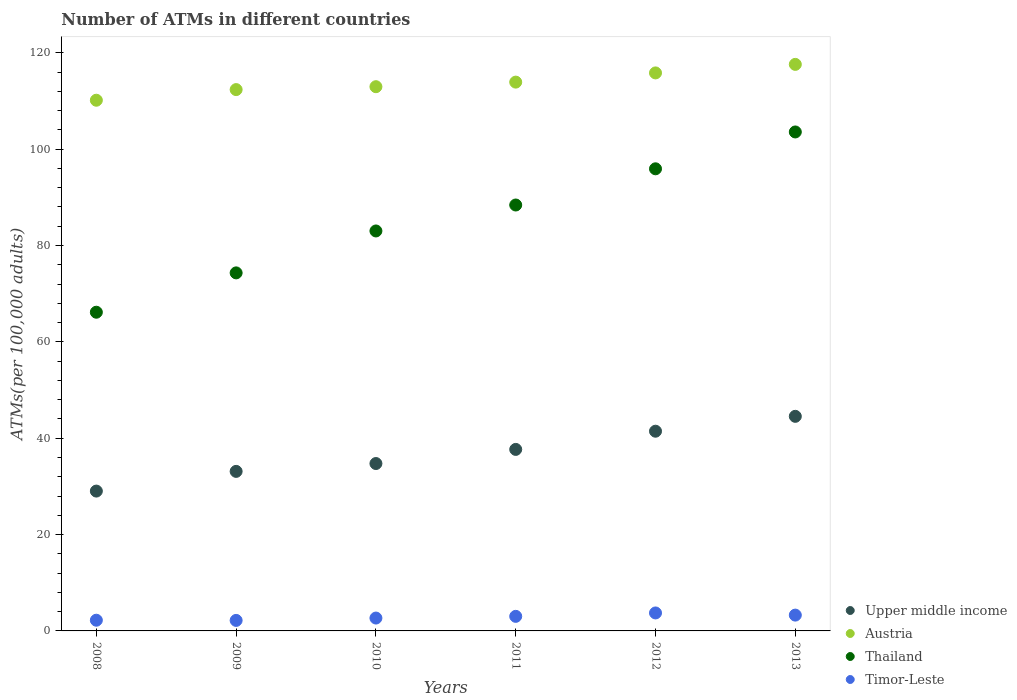How many different coloured dotlines are there?
Your answer should be very brief. 4. Is the number of dotlines equal to the number of legend labels?
Keep it short and to the point. Yes. What is the number of ATMs in Thailand in 2009?
Your answer should be compact. 74.32. Across all years, what is the maximum number of ATMs in Upper middle income?
Ensure brevity in your answer.  44.54. Across all years, what is the minimum number of ATMs in Thailand?
Your answer should be compact. 66.15. In which year was the number of ATMs in Thailand minimum?
Give a very brief answer. 2008. What is the total number of ATMs in Thailand in the graph?
Make the answer very short. 511.39. What is the difference between the number of ATMs in Austria in 2008 and that in 2009?
Your response must be concise. -2.21. What is the difference between the number of ATMs in Austria in 2012 and the number of ATMs in Upper middle income in 2009?
Provide a succinct answer. 82.71. What is the average number of ATMs in Austria per year?
Your answer should be very brief. 113.8. In the year 2012, what is the difference between the number of ATMs in Timor-Leste and number of ATMs in Upper middle income?
Give a very brief answer. -37.72. In how many years, is the number of ATMs in Austria greater than 112?
Keep it short and to the point. 5. What is the ratio of the number of ATMs in Thailand in 2009 to that in 2012?
Offer a terse response. 0.77. Is the number of ATMs in Thailand in 2012 less than that in 2013?
Keep it short and to the point. Yes. What is the difference between the highest and the second highest number of ATMs in Austria?
Offer a terse response. 1.77. What is the difference between the highest and the lowest number of ATMs in Austria?
Give a very brief answer. 7.44. Is it the case that in every year, the sum of the number of ATMs in Austria and number of ATMs in Thailand  is greater than the number of ATMs in Timor-Leste?
Offer a very short reply. Yes. Is the number of ATMs in Upper middle income strictly greater than the number of ATMs in Austria over the years?
Offer a terse response. No. Are the values on the major ticks of Y-axis written in scientific E-notation?
Offer a terse response. No. How many legend labels are there?
Provide a succinct answer. 4. What is the title of the graph?
Ensure brevity in your answer.  Number of ATMs in different countries. Does "Azerbaijan" appear as one of the legend labels in the graph?
Provide a short and direct response. No. What is the label or title of the X-axis?
Make the answer very short. Years. What is the label or title of the Y-axis?
Provide a short and direct response. ATMs(per 100,0 adults). What is the ATMs(per 100,000 adults) of Upper middle income in 2008?
Provide a succinct answer. 29.03. What is the ATMs(per 100,000 adults) in Austria in 2008?
Your answer should be compact. 110.16. What is the ATMs(per 100,000 adults) in Thailand in 2008?
Provide a succinct answer. 66.15. What is the ATMs(per 100,000 adults) of Timor-Leste in 2008?
Your response must be concise. 2.22. What is the ATMs(per 100,000 adults) in Upper middle income in 2009?
Offer a very short reply. 33.12. What is the ATMs(per 100,000 adults) in Austria in 2009?
Offer a terse response. 112.36. What is the ATMs(per 100,000 adults) in Thailand in 2009?
Your answer should be very brief. 74.32. What is the ATMs(per 100,000 adults) of Timor-Leste in 2009?
Ensure brevity in your answer.  2.18. What is the ATMs(per 100,000 adults) in Upper middle income in 2010?
Your answer should be compact. 34.74. What is the ATMs(per 100,000 adults) in Austria in 2010?
Your answer should be very brief. 112.97. What is the ATMs(per 100,000 adults) of Thailand in 2010?
Offer a very short reply. 83.02. What is the ATMs(per 100,000 adults) of Timor-Leste in 2010?
Give a very brief answer. 2.67. What is the ATMs(per 100,000 adults) of Upper middle income in 2011?
Your answer should be very brief. 37.68. What is the ATMs(per 100,000 adults) of Austria in 2011?
Ensure brevity in your answer.  113.92. What is the ATMs(per 100,000 adults) of Thailand in 2011?
Give a very brief answer. 88.41. What is the ATMs(per 100,000 adults) in Timor-Leste in 2011?
Offer a terse response. 3.02. What is the ATMs(per 100,000 adults) of Upper middle income in 2012?
Give a very brief answer. 41.45. What is the ATMs(per 100,000 adults) in Austria in 2012?
Your answer should be compact. 115.83. What is the ATMs(per 100,000 adults) of Thailand in 2012?
Your answer should be very brief. 95.92. What is the ATMs(per 100,000 adults) in Timor-Leste in 2012?
Your answer should be very brief. 3.73. What is the ATMs(per 100,000 adults) of Upper middle income in 2013?
Make the answer very short. 44.54. What is the ATMs(per 100,000 adults) of Austria in 2013?
Your response must be concise. 117.6. What is the ATMs(per 100,000 adults) of Thailand in 2013?
Your answer should be compact. 103.57. What is the ATMs(per 100,000 adults) in Timor-Leste in 2013?
Your response must be concise. 3.28. Across all years, what is the maximum ATMs(per 100,000 adults) of Upper middle income?
Provide a succinct answer. 44.54. Across all years, what is the maximum ATMs(per 100,000 adults) of Austria?
Your answer should be very brief. 117.6. Across all years, what is the maximum ATMs(per 100,000 adults) in Thailand?
Provide a succinct answer. 103.57. Across all years, what is the maximum ATMs(per 100,000 adults) of Timor-Leste?
Ensure brevity in your answer.  3.73. Across all years, what is the minimum ATMs(per 100,000 adults) of Upper middle income?
Provide a short and direct response. 29.03. Across all years, what is the minimum ATMs(per 100,000 adults) in Austria?
Provide a short and direct response. 110.16. Across all years, what is the minimum ATMs(per 100,000 adults) of Thailand?
Ensure brevity in your answer.  66.15. Across all years, what is the minimum ATMs(per 100,000 adults) in Timor-Leste?
Make the answer very short. 2.18. What is the total ATMs(per 100,000 adults) in Upper middle income in the graph?
Ensure brevity in your answer.  220.56. What is the total ATMs(per 100,000 adults) of Austria in the graph?
Your answer should be compact. 682.82. What is the total ATMs(per 100,000 adults) of Thailand in the graph?
Make the answer very short. 511.39. What is the total ATMs(per 100,000 adults) of Timor-Leste in the graph?
Your answer should be very brief. 17.11. What is the difference between the ATMs(per 100,000 adults) of Upper middle income in 2008 and that in 2009?
Your answer should be compact. -4.09. What is the difference between the ATMs(per 100,000 adults) in Austria in 2008 and that in 2009?
Offer a terse response. -2.21. What is the difference between the ATMs(per 100,000 adults) in Thailand in 2008 and that in 2009?
Your answer should be compact. -8.17. What is the difference between the ATMs(per 100,000 adults) of Timor-Leste in 2008 and that in 2009?
Keep it short and to the point. 0.04. What is the difference between the ATMs(per 100,000 adults) in Upper middle income in 2008 and that in 2010?
Provide a short and direct response. -5.72. What is the difference between the ATMs(per 100,000 adults) in Austria in 2008 and that in 2010?
Ensure brevity in your answer.  -2.81. What is the difference between the ATMs(per 100,000 adults) in Thailand in 2008 and that in 2010?
Your answer should be compact. -16.87. What is the difference between the ATMs(per 100,000 adults) of Timor-Leste in 2008 and that in 2010?
Offer a very short reply. -0.45. What is the difference between the ATMs(per 100,000 adults) in Upper middle income in 2008 and that in 2011?
Ensure brevity in your answer.  -8.65. What is the difference between the ATMs(per 100,000 adults) in Austria in 2008 and that in 2011?
Offer a terse response. -3.76. What is the difference between the ATMs(per 100,000 adults) of Thailand in 2008 and that in 2011?
Give a very brief answer. -22.26. What is the difference between the ATMs(per 100,000 adults) in Timor-Leste in 2008 and that in 2011?
Provide a succinct answer. -0.8. What is the difference between the ATMs(per 100,000 adults) of Upper middle income in 2008 and that in 2012?
Offer a terse response. -12.43. What is the difference between the ATMs(per 100,000 adults) in Austria in 2008 and that in 2012?
Offer a terse response. -5.67. What is the difference between the ATMs(per 100,000 adults) in Thailand in 2008 and that in 2012?
Your answer should be compact. -29.77. What is the difference between the ATMs(per 100,000 adults) in Timor-Leste in 2008 and that in 2012?
Your response must be concise. -1.51. What is the difference between the ATMs(per 100,000 adults) of Upper middle income in 2008 and that in 2013?
Provide a succinct answer. -15.51. What is the difference between the ATMs(per 100,000 adults) of Austria in 2008 and that in 2013?
Keep it short and to the point. -7.44. What is the difference between the ATMs(per 100,000 adults) in Thailand in 2008 and that in 2013?
Provide a short and direct response. -37.42. What is the difference between the ATMs(per 100,000 adults) in Timor-Leste in 2008 and that in 2013?
Keep it short and to the point. -1.06. What is the difference between the ATMs(per 100,000 adults) in Upper middle income in 2009 and that in 2010?
Provide a succinct answer. -1.63. What is the difference between the ATMs(per 100,000 adults) in Austria in 2009 and that in 2010?
Your answer should be compact. -0.6. What is the difference between the ATMs(per 100,000 adults) of Thailand in 2009 and that in 2010?
Your answer should be very brief. -8.7. What is the difference between the ATMs(per 100,000 adults) of Timor-Leste in 2009 and that in 2010?
Make the answer very short. -0.49. What is the difference between the ATMs(per 100,000 adults) in Upper middle income in 2009 and that in 2011?
Make the answer very short. -4.56. What is the difference between the ATMs(per 100,000 adults) in Austria in 2009 and that in 2011?
Offer a terse response. -1.55. What is the difference between the ATMs(per 100,000 adults) in Thailand in 2009 and that in 2011?
Provide a succinct answer. -14.09. What is the difference between the ATMs(per 100,000 adults) in Timor-Leste in 2009 and that in 2011?
Your answer should be compact. -0.84. What is the difference between the ATMs(per 100,000 adults) in Upper middle income in 2009 and that in 2012?
Provide a short and direct response. -8.34. What is the difference between the ATMs(per 100,000 adults) of Austria in 2009 and that in 2012?
Your answer should be very brief. -3.46. What is the difference between the ATMs(per 100,000 adults) of Thailand in 2009 and that in 2012?
Provide a short and direct response. -21.6. What is the difference between the ATMs(per 100,000 adults) in Timor-Leste in 2009 and that in 2012?
Make the answer very short. -1.55. What is the difference between the ATMs(per 100,000 adults) in Upper middle income in 2009 and that in 2013?
Give a very brief answer. -11.43. What is the difference between the ATMs(per 100,000 adults) in Austria in 2009 and that in 2013?
Offer a very short reply. -5.23. What is the difference between the ATMs(per 100,000 adults) of Thailand in 2009 and that in 2013?
Keep it short and to the point. -29.25. What is the difference between the ATMs(per 100,000 adults) of Timor-Leste in 2009 and that in 2013?
Offer a terse response. -1.1. What is the difference between the ATMs(per 100,000 adults) of Upper middle income in 2010 and that in 2011?
Your answer should be very brief. -2.93. What is the difference between the ATMs(per 100,000 adults) in Austria in 2010 and that in 2011?
Offer a terse response. -0.95. What is the difference between the ATMs(per 100,000 adults) in Thailand in 2010 and that in 2011?
Your answer should be very brief. -5.39. What is the difference between the ATMs(per 100,000 adults) of Timor-Leste in 2010 and that in 2011?
Offer a terse response. -0.35. What is the difference between the ATMs(per 100,000 adults) in Upper middle income in 2010 and that in 2012?
Your response must be concise. -6.71. What is the difference between the ATMs(per 100,000 adults) of Austria in 2010 and that in 2012?
Offer a terse response. -2.86. What is the difference between the ATMs(per 100,000 adults) of Thailand in 2010 and that in 2012?
Offer a terse response. -12.9. What is the difference between the ATMs(per 100,000 adults) of Timor-Leste in 2010 and that in 2012?
Ensure brevity in your answer.  -1.06. What is the difference between the ATMs(per 100,000 adults) in Upper middle income in 2010 and that in 2013?
Ensure brevity in your answer.  -9.8. What is the difference between the ATMs(per 100,000 adults) of Austria in 2010 and that in 2013?
Give a very brief answer. -4.63. What is the difference between the ATMs(per 100,000 adults) in Thailand in 2010 and that in 2013?
Provide a short and direct response. -20.55. What is the difference between the ATMs(per 100,000 adults) in Timor-Leste in 2010 and that in 2013?
Provide a short and direct response. -0.61. What is the difference between the ATMs(per 100,000 adults) in Upper middle income in 2011 and that in 2012?
Keep it short and to the point. -3.78. What is the difference between the ATMs(per 100,000 adults) in Austria in 2011 and that in 2012?
Your response must be concise. -1.91. What is the difference between the ATMs(per 100,000 adults) in Thailand in 2011 and that in 2012?
Provide a succinct answer. -7.51. What is the difference between the ATMs(per 100,000 adults) of Timor-Leste in 2011 and that in 2012?
Your answer should be very brief. -0.7. What is the difference between the ATMs(per 100,000 adults) of Upper middle income in 2011 and that in 2013?
Keep it short and to the point. -6.86. What is the difference between the ATMs(per 100,000 adults) of Austria in 2011 and that in 2013?
Provide a short and direct response. -3.68. What is the difference between the ATMs(per 100,000 adults) of Thailand in 2011 and that in 2013?
Offer a terse response. -15.16. What is the difference between the ATMs(per 100,000 adults) of Timor-Leste in 2011 and that in 2013?
Provide a short and direct response. -0.26. What is the difference between the ATMs(per 100,000 adults) in Upper middle income in 2012 and that in 2013?
Your response must be concise. -3.09. What is the difference between the ATMs(per 100,000 adults) in Austria in 2012 and that in 2013?
Provide a succinct answer. -1.77. What is the difference between the ATMs(per 100,000 adults) of Thailand in 2012 and that in 2013?
Keep it short and to the point. -7.65. What is the difference between the ATMs(per 100,000 adults) of Timor-Leste in 2012 and that in 2013?
Keep it short and to the point. 0.45. What is the difference between the ATMs(per 100,000 adults) of Upper middle income in 2008 and the ATMs(per 100,000 adults) of Austria in 2009?
Make the answer very short. -83.34. What is the difference between the ATMs(per 100,000 adults) in Upper middle income in 2008 and the ATMs(per 100,000 adults) in Thailand in 2009?
Provide a succinct answer. -45.29. What is the difference between the ATMs(per 100,000 adults) in Upper middle income in 2008 and the ATMs(per 100,000 adults) in Timor-Leste in 2009?
Make the answer very short. 26.85. What is the difference between the ATMs(per 100,000 adults) in Austria in 2008 and the ATMs(per 100,000 adults) in Thailand in 2009?
Offer a terse response. 35.84. What is the difference between the ATMs(per 100,000 adults) in Austria in 2008 and the ATMs(per 100,000 adults) in Timor-Leste in 2009?
Offer a terse response. 107.97. What is the difference between the ATMs(per 100,000 adults) of Thailand in 2008 and the ATMs(per 100,000 adults) of Timor-Leste in 2009?
Offer a very short reply. 63.97. What is the difference between the ATMs(per 100,000 adults) of Upper middle income in 2008 and the ATMs(per 100,000 adults) of Austria in 2010?
Provide a short and direct response. -83.94. What is the difference between the ATMs(per 100,000 adults) in Upper middle income in 2008 and the ATMs(per 100,000 adults) in Thailand in 2010?
Make the answer very short. -53.99. What is the difference between the ATMs(per 100,000 adults) of Upper middle income in 2008 and the ATMs(per 100,000 adults) of Timor-Leste in 2010?
Your answer should be compact. 26.36. What is the difference between the ATMs(per 100,000 adults) of Austria in 2008 and the ATMs(per 100,000 adults) of Thailand in 2010?
Offer a very short reply. 27.14. What is the difference between the ATMs(per 100,000 adults) in Austria in 2008 and the ATMs(per 100,000 adults) in Timor-Leste in 2010?
Your answer should be very brief. 107.49. What is the difference between the ATMs(per 100,000 adults) in Thailand in 2008 and the ATMs(per 100,000 adults) in Timor-Leste in 2010?
Offer a very short reply. 63.48. What is the difference between the ATMs(per 100,000 adults) in Upper middle income in 2008 and the ATMs(per 100,000 adults) in Austria in 2011?
Provide a short and direct response. -84.89. What is the difference between the ATMs(per 100,000 adults) in Upper middle income in 2008 and the ATMs(per 100,000 adults) in Thailand in 2011?
Make the answer very short. -59.38. What is the difference between the ATMs(per 100,000 adults) in Upper middle income in 2008 and the ATMs(per 100,000 adults) in Timor-Leste in 2011?
Offer a very short reply. 26. What is the difference between the ATMs(per 100,000 adults) of Austria in 2008 and the ATMs(per 100,000 adults) of Thailand in 2011?
Keep it short and to the point. 21.75. What is the difference between the ATMs(per 100,000 adults) in Austria in 2008 and the ATMs(per 100,000 adults) in Timor-Leste in 2011?
Your response must be concise. 107.13. What is the difference between the ATMs(per 100,000 adults) of Thailand in 2008 and the ATMs(per 100,000 adults) of Timor-Leste in 2011?
Your response must be concise. 63.13. What is the difference between the ATMs(per 100,000 adults) in Upper middle income in 2008 and the ATMs(per 100,000 adults) in Austria in 2012?
Your response must be concise. -86.8. What is the difference between the ATMs(per 100,000 adults) of Upper middle income in 2008 and the ATMs(per 100,000 adults) of Thailand in 2012?
Ensure brevity in your answer.  -66.9. What is the difference between the ATMs(per 100,000 adults) in Upper middle income in 2008 and the ATMs(per 100,000 adults) in Timor-Leste in 2012?
Your answer should be very brief. 25.3. What is the difference between the ATMs(per 100,000 adults) of Austria in 2008 and the ATMs(per 100,000 adults) of Thailand in 2012?
Keep it short and to the point. 14.23. What is the difference between the ATMs(per 100,000 adults) in Austria in 2008 and the ATMs(per 100,000 adults) in Timor-Leste in 2012?
Your answer should be very brief. 106.43. What is the difference between the ATMs(per 100,000 adults) in Thailand in 2008 and the ATMs(per 100,000 adults) in Timor-Leste in 2012?
Provide a short and direct response. 62.42. What is the difference between the ATMs(per 100,000 adults) in Upper middle income in 2008 and the ATMs(per 100,000 adults) in Austria in 2013?
Keep it short and to the point. -88.57. What is the difference between the ATMs(per 100,000 adults) of Upper middle income in 2008 and the ATMs(per 100,000 adults) of Thailand in 2013?
Your response must be concise. -74.54. What is the difference between the ATMs(per 100,000 adults) of Upper middle income in 2008 and the ATMs(per 100,000 adults) of Timor-Leste in 2013?
Make the answer very short. 25.74. What is the difference between the ATMs(per 100,000 adults) of Austria in 2008 and the ATMs(per 100,000 adults) of Thailand in 2013?
Your answer should be very brief. 6.59. What is the difference between the ATMs(per 100,000 adults) of Austria in 2008 and the ATMs(per 100,000 adults) of Timor-Leste in 2013?
Your response must be concise. 106.87. What is the difference between the ATMs(per 100,000 adults) in Thailand in 2008 and the ATMs(per 100,000 adults) in Timor-Leste in 2013?
Your response must be concise. 62.87. What is the difference between the ATMs(per 100,000 adults) in Upper middle income in 2009 and the ATMs(per 100,000 adults) in Austria in 2010?
Offer a very short reply. -79.85. What is the difference between the ATMs(per 100,000 adults) of Upper middle income in 2009 and the ATMs(per 100,000 adults) of Thailand in 2010?
Make the answer very short. -49.91. What is the difference between the ATMs(per 100,000 adults) of Upper middle income in 2009 and the ATMs(per 100,000 adults) of Timor-Leste in 2010?
Give a very brief answer. 30.44. What is the difference between the ATMs(per 100,000 adults) of Austria in 2009 and the ATMs(per 100,000 adults) of Thailand in 2010?
Provide a succinct answer. 29.34. What is the difference between the ATMs(per 100,000 adults) of Austria in 2009 and the ATMs(per 100,000 adults) of Timor-Leste in 2010?
Make the answer very short. 109.69. What is the difference between the ATMs(per 100,000 adults) of Thailand in 2009 and the ATMs(per 100,000 adults) of Timor-Leste in 2010?
Provide a succinct answer. 71.65. What is the difference between the ATMs(per 100,000 adults) of Upper middle income in 2009 and the ATMs(per 100,000 adults) of Austria in 2011?
Offer a terse response. -80.8. What is the difference between the ATMs(per 100,000 adults) in Upper middle income in 2009 and the ATMs(per 100,000 adults) in Thailand in 2011?
Give a very brief answer. -55.29. What is the difference between the ATMs(per 100,000 adults) of Upper middle income in 2009 and the ATMs(per 100,000 adults) of Timor-Leste in 2011?
Your response must be concise. 30.09. What is the difference between the ATMs(per 100,000 adults) of Austria in 2009 and the ATMs(per 100,000 adults) of Thailand in 2011?
Ensure brevity in your answer.  23.96. What is the difference between the ATMs(per 100,000 adults) of Austria in 2009 and the ATMs(per 100,000 adults) of Timor-Leste in 2011?
Your answer should be very brief. 109.34. What is the difference between the ATMs(per 100,000 adults) of Thailand in 2009 and the ATMs(per 100,000 adults) of Timor-Leste in 2011?
Your answer should be compact. 71.29. What is the difference between the ATMs(per 100,000 adults) in Upper middle income in 2009 and the ATMs(per 100,000 adults) in Austria in 2012?
Your answer should be very brief. -82.71. What is the difference between the ATMs(per 100,000 adults) of Upper middle income in 2009 and the ATMs(per 100,000 adults) of Thailand in 2012?
Give a very brief answer. -62.81. What is the difference between the ATMs(per 100,000 adults) in Upper middle income in 2009 and the ATMs(per 100,000 adults) in Timor-Leste in 2012?
Provide a succinct answer. 29.39. What is the difference between the ATMs(per 100,000 adults) of Austria in 2009 and the ATMs(per 100,000 adults) of Thailand in 2012?
Offer a terse response. 16.44. What is the difference between the ATMs(per 100,000 adults) of Austria in 2009 and the ATMs(per 100,000 adults) of Timor-Leste in 2012?
Offer a very short reply. 108.63. What is the difference between the ATMs(per 100,000 adults) of Thailand in 2009 and the ATMs(per 100,000 adults) of Timor-Leste in 2012?
Your answer should be compact. 70.59. What is the difference between the ATMs(per 100,000 adults) of Upper middle income in 2009 and the ATMs(per 100,000 adults) of Austria in 2013?
Provide a short and direct response. -84.48. What is the difference between the ATMs(per 100,000 adults) of Upper middle income in 2009 and the ATMs(per 100,000 adults) of Thailand in 2013?
Provide a succinct answer. -70.45. What is the difference between the ATMs(per 100,000 adults) in Upper middle income in 2009 and the ATMs(per 100,000 adults) in Timor-Leste in 2013?
Your answer should be compact. 29.83. What is the difference between the ATMs(per 100,000 adults) in Austria in 2009 and the ATMs(per 100,000 adults) in Thailand in 2013?
Give a very brief answer. 8.79. What is the difference between the ATMs(per 100,000 adults) of Austria in 2009 and the ATMs(per 100,000 adults) of Timor-Leste in 2013?
Give a very brief answer. 109.08. What is the difference between the ATMs(per 100,000 adults) of Thailand in 2009 and the ATMs(per 100,000 adults) of Timor-Leste in 2013?
Offer a terse response. 71.04. What is the difference between the ATMs(per 100,000 adults) of Upper middle income in 2010 and the ATMs(per 100,000 adults) of Austria in 2011?
Offer a very short reply. -79.17. What is the difference between the ATMs(per 100,000 adults) in Upper middle income in 2010 and the ATMs(per 100,000 adults) in Thailand in 2011?
Provide a short and direct response. -53.66. What is the difference between the ATMs(per 100,000 adults) of Upper middle income in 2010 and the ATMs(per 100,000 adults) of Timor-Leste in 2011?
Your answer should be compact. 31.72. What is the difference between the ATMs(per 100,000 adults) of Austria in 2010 and the ATMs(per 100,000 adults) of Thailand in 2011?
Ensure brevity in your answer.  24.56. What is the difference between the ATMs(per 100,000 adults) in Austria in 2010 and the ATMs(per 100,000 adults) in Timor-Leste in 2011?
Your answer should be compact. 109.94. What is the difference between the ATMs(per 100,000 adults) of Thailand in 2010 and the ATMs(per 100,000 adults) of Timor-Leste in 2011?
Offer a very short reply. 80. What is the difference between the ATMs(per 100,000 adults) of Upper middle income in 2010 and the ATMs(per 100,000 adults) of Austria in 2012?
Your answer should be very brief. -81.08. What is the difference between the ATMs(per 100,000 adults) in Upper middle income in 2010 and the ATMs(per 100,000 adults) in Thailand in 2012?
Offer a terse response. -61.18. What is the difference between the ATMs(per 100,000 adults) of Upper middle income in 2010 and the ATMs(per 100,000 adults) of Timor-Leste in 2012?
Your response must be concise. 31.02. What is the difference between the ATMs(per 100,000 adults) in Austria in 2010 and the ATMs(per 100,000 adults) in Thailand in 2012?
Offer a terse response. 17.04. What is the difference between the ATMs(per 100,000 adults) of Austria in 2010 and the ATMs(per 100,000 adults) of Timor-Leste in 2012?
Your response must be concise. 109.24. What is the difference between the ATMs(per 100,000 adults) of Thailand in 2010 and the ATMs(per 100,000 adults) of Timor-Leste in 2012?
Your response must be concise. 79.29. What is the difference between the ATMs(per 100,000 adults) of Upper middle income in 2010 and the ATMs(per 100,000 adults) of Austria in 2013?
Ensure brevity in your answer.  -82.85. What is the difference between the ATMs(per 100,000 adults) of Upper middle income in 2010 and the ATMs(per 100,000 adults) of Thailand in 2013?
Offer a very short reply. -68.83. What is the difference between the ATMs(per 100,000 adults) of Upper middle income in 2010 and the ATMs(per 100,000 adults) of Timor-Leste in 2013?
Make the answer very short. 31.46. What is the difference between the ATMs(per 100,000 adults) in Austria in 2010 and the ATMs(per 100,000 adults) in Thailand in 2013?
Offer a terse response. 9.4. What is the difference between the ATMs(per 100,000 adults) in Austria in 2010 and the ATMs(per 100,000 adults) in Timor-Leste in 2013?
Make the answer very short. 109.68. What is the difference between the ATMs(per 100,000 adults) of Thailand in 2010 and the ATMs(per 100,000 adults) of Timor-Leste in 2013?
Provide a succinct answer. 79.74. What is the difference between the ATMs(per 100,000 adults) of Upper middle income in 2011 and the ATMs(per 100,000 adults) of Austria in 2012?
Your response must be concise. -78.15. What is the difference between the ATMs(per 100,000 adults) in Upper middle income in 2011 and the ATMs(per 100,000 adults) in Thailand in 2012?
Your answer should be compact. -58.25. What is the difference between the ATMs(per 100,000 adults) in Upper middle income in 2011 and the ATMs(per 100,000 adults) in Timor-Leste in 2012?
Offer a very short reply. 33.95. What is the difference between the ATMs(per 100,000 adults) of Austria in 2011 and the ATMs(per 100,000 adults) of Thailand in 2012?
Your answer should be very brief. 17.99. What is the difference between the ATMs(per 100,000 adults) in Austria in 2011 and the ATMs(per 100,000 adults) in Timor-Leste in 2012?
Your answer should be very brief. 110.19. What is the difference between the ATMs(per 100,000 adults) of Thailand in 2011 and the ATMs(per 100,000 adults) of Timor-Leste in 2012?
Your answer should be compact. 84.68. What is the difference between the ATMs(per 100,000 adults) of Upper middle income in 2011 and the ATMs(per 100,000 adults) of Austria in 2013?
Offer a terse response. -79.92. What is the difference between the ATMs(per 100,000 adults) of Upper middle income in 2011 and the ATMs(per 100,000 adults) of Thailand in 2013?
Provide a succinct answer. -65.89. What is the difference between the ATMs(per 100,000 adults) of Upper middle income in 2011 and the ATMs(per 100,000 adults) of Timor-Leste in 2013?
Offer a terse response. 34.39. What is the difference between the ATMs(per 100,000 adults) in Austria in 2011 and the ATMs(per 100,000 adults) in Thailand in 2013?
Keep it short and to the point. 10.35. What is the difference between the ATMs(per 100,000 adults) in Austria in 2011 and the ATMs(per 100,000 adults) in Timor-Leste in 2013?
Your answer should be compact. 110.63. What is the difference between the ATMs(per 100,000 adults) in Thailand in 2011 and the ATMs(per 100,000 adults) in Timor-Leste in 2013?
Provide a succinct answer. 85.13. What is the difference between the ATMs(per 100,000 adults) in Upper middle income in 2012 and the ATMs(per 100,000 adults) in Austria in 2013?
Keep it short and to the point. -76.14. What is the difference between the ATMs(per 100,000 adults) of Upper middle income in 2012 and the ATMs(per 100,000 adults) of Thailand in 2013?
Provide a succinct answer. -62.12. What is the difference between the ATMs(per 100,000 adults) in Upper middle income in 2012 and the ATMs(per 100,000 adults) in Timor-Leste in 2013?
Offer a terse response. 38.17. What is the difference between the ATMs(per 100,000 adults) of Austria in 2012 and the ATMs(per 100,000 adults) of Thailand in 2013?
Offer a terse response. 12.26. What is the difference between the ATMs(per 100,000 adults) of Austria in 2012 and the ATMs(per 100,000 adults) of Timor-Leste in 2013?
Make the answer very short. 112.54. What is the difference between the ATMs(per 100,000 adults) of Thailand in 2012 and the ATMs(per 100,000 adults) of Timor-Leste in 2013?
Provide a short and direct response. 92.64. What is the average ATMs(per 100,000 adults) in Upper middle income per year?
Offer a very short reply. 36.76. What is the average ATMs(per 100,000 adults) of Austria per year?
Keep it short and to the point. 113.8. What is the average ATMs(per 100,000 adults) of Thailand per year?
Provide a succinct answer. 85.23. What is the average ATMs(per 100,000 adults) of Timor-Leste per year?
Your answer should be very brief. 2.85. In the year 2008, what is the difference between the ATMs(per 100,000 adults) in Upper middle income and ATMs(per 100,000 adults) in Austria?
Your answer should be compact. -81.13. In the year 2008, what is the difference between the ATMs(per 100,000 adults) of Upper middle income and ATMs(per 100,000 adults) of Thailand?
Make the answer very short. -37.13. In the year 2008, what is the difference between the ATMs(per 100,000 adults) in Upper middle income and ATMs(per 100,000 adults) in Timor-Leste?
Offer a terse response. 26.81. In the year 2008, what is the difference between the ATMs(per 100,000 adults) of Austria and ATMs(per 100,000 adults) of Thailand?
Make the answer very short. 44. In the year 2008, what is the difference between the ATMs(per 100,000 adults) in Austria and ATMs(per 100,000 adults) in Timor-Leste?
Offer a terse response. 107.93. In the year 2008, what is the difference between the ATMs(per 100,000 adults) in Thailand and ATMs(per 100,000 adults) in Timor-Leste?
Your answer should be compact. 63.93. In the year 2009, what is the difference between the ATMs(per 100,000 adults) of Upper middle income and ATMs(per 100,000 adults) of Austria?
Provide a short and direct response. -79.25. In the year 2009, what is the difference between the ATMs(per 100,000 adults) of Upper middle income and ATMs(per 100,000 adults) of Thailand?
Provide a succinct answer. -41.2. In the year 2009, what is the difference between the ATMs(per 100,000 adults) of Upper middle income and ATMs(per 100,000 adults) of Timor-Leste?
Provide a short and direct response. 30.93. In the year 2009, what is the difference between the ATMs(per 100,000 adults) in Austria and ATMs(per 100,000 adults) in Thailand?
Ensure brevity in your answer.  38.05. In the year 2009, what is the difference between the ATMs(per 100,000 adults) in Austria and ATMs(per 100,000 adults) in Timor-Leste?
Your answer should be very brief. 110.18. In the year 2009, what is the difference between the ATMs(per 100,000 adults) of Thailand and ATMs(per 100,000 adults) of Timor-Leste?
Your answer should be very brief. 72.14. In the year 2010, what is the difference between the ATMs(per 100,000 adults) of Upper middle income and ATMs(per 100,000 adults) of Austria?
Keep it short and to the point. -78.22. In the year 2010, what is the difference between the ATMs(per 100,000 adults) of Upper middle income and ATMs(per 100,000 adults) of Thailand?
Offer a very short reply. -48.28. In the year 2010, what is the difference between the ATMs(per 100,000 adults) of Upper middle income and ATMs(per 100,000 adults) of Timor-Leste?
Provide a short and direct response. 32.07. In the year 2010, what is the difference between the ATMs(per 100,000 adults) in Austria and ATMs(per 100,000 adults) in Thailand?
Provide a short and direct response. 29.95. In the year 2010, what is the difference between the ATMs(per 100,000 adults) of Austria and ATMs(per 100,000 adults) of Timor-Leste?
Keep it short and to the point. 110.3. In the year 2010, what is the difference between the ATMs(per 100,000 adults) of Thailand and ATMs(per 100,000 adults) of Timor-Leste?
Ensure brevity in your answer.  80.35. In the year 2011, what is the difference between the ATMs(per 100,000 adults) in Upper middle income and ATMs(per 100,000 adults) in Austria?
Your answer should be very brief. -76.24. In the year 2011, what is the difference between the ATMs(per 100,000 adults) in Upper middle income and ATMs(per 100,000 adults) in Thailand?
Provide a short and direct response. -50.73. In the year 2011, what is the difference between the ATMs(per 100,000 adults) in Upper middle income and ATMs(per 100,000 adults) in Timor-Leste?
Offer a terse response. 34.65. In the year 2011, what is the difference between the ATMs(per 100,000 adults) in Austria and ATMs(per 100,000 adults) in Thailand?
Provide a short and direct response. 25.51. In the year 2011, what is the difference between the ATMs(per 100,000 adults) of Austria and ATMs(per 100,000 adults) of Timor-Leste?
Make the answer very short. 110.89. In the year 2011, what is the difference between the ATMs(per 100,000 adults) of Thailand and ATMs(per 100,000 adults) of Timor-Leste?
Ensure brevity in your answer.  85.38. In the year 2012, what is the difference between the ATMs(per 100,000 adults) of Upper middle income and ATMs(per 100,000 adults) of Austria?
Offer a very short reply. -74.37. In the year 2012, what is the difference between the ATMs(per 100,000 adults) in Upper middle income and ATMs(per 100,000 adults) in Thailand?
Provide a short and direct response. -54.47. In the year 2012, what is the difference between the ATMs(per 100,000 adults) in Upper middle income and ATMs(per 100,000 adults) in Timor-Leste?
Provide a succinct answer. 37.72. In the year 2012, what is the difference between the ATMs(per 100,000 adults) in Austria and ATMs(per 100,000 adults) in Thailand?
Provide a short and direct response. 19.9. In the year 2012, what is the difference between the ATMs(per 100,000 adults) of Austria and ATMs(per 100,000 adults) of Timor-Leste?
Your answer should be very brief. 112.1. In the year 2012, what is the difference between the ATMs(per 100,000 adults) of Thailand and ATMs(per 100,000 adults) of Timor-Leste?
Your answer should be very brief. 92.19. In the year 2013, what is the difference between the ATMs(per 100,000 adults) of Upper middle income and ATMs(per 100,000 adults) of Austria?
Give a very brief answer. -73.06. In the year 2013, what is the difference between the ATMs(per 100,000 adults) in Upper middle income and ATMs(per 100,000 adults) in Thailand?
Your response must be concise. -59.03. In the year 2013, what is the difference between the ATMs(per 100,000 adults) of Upper middle income and ATMs(per 100,000 adults) of Timor-Leste?
Ensure brevity in your answer.  41.26. In the year 2013, what is the difference between the ATMs(per 100,000 adults) of Austria and ATMs(per 100,000 adults) of Thailand?
Provide a succinct answer. 14.03. In the year 2013, what is the difference between the ATMs(per 100,000 adults) in Austria and ATMs(per 100,000 adults) in Timor-Leste?
Your answer should be compact. 114.32. In the year 2013, what is the difference between the ATMs(per 100,000 adults) of Thailand and ATMs(per 100,000 adults) of Timor-Leste?
Ensure brevity in your answer.  100.29. What is the ratio of the ATMs(per 100,000 adults) of Upper middle income in 2008 to that in 2009?
Keep it short and to the point. 0.88. What is the ratio of the ATMs(per 100,000 adults) in Austria in 2008 to that in 2009?
Your response must be concise. 0.98. What is the ratio of the ATMs(per 100,000 adults) of Thailand in 2008 to that in 2009?
Offer a very short reply. 0.89. What is the ratio of the ATMs(per 100,000 adults) of Timor-Leste in 2008 to that in 2009?
Your response must be concise. 1.02. What is the ratio of the ATMs(per 100,000 adults) of Upper middle income in 2008 to that in 2010?
Offer a terse response. 0.84. What is the ratio of the ATMs(per 100,000 adults) in Austria in 2008 to that in 2010?
Ensure brevity in your answer.  0.98. What is the ratio of the ATMs(per 100,000 adults) in Thailand in 2008 to that in 2010?
Your answer should be very brief. 0.8. What is the ratio of the ATMs(per 100,000 adults) in Timor-Leste in 2008 to that in 2010?
Offer a terse response. 0.83. What is the ratio of the ATMs(per 100,000 adults) in Upper middle income in 2008 to that in 2011?
Make the answer very short. 0.77. What is the ratio of the ATMs(per 100,000 adults) of Thailand in 2008 to that in 2011?
Keep it short and to the point. 0.75. What is the ratio of the ATMs(per 100,000 adults) in Timor-Leste in 2008 to that in 2011?
Ensure brevity in your answer.  0.73. What is the ratio of the ATMs(per 100,000 adults) of Upper middle income in 2008 to that in 2012?
Make the answer very short. 0.7. What is the ratio of the ATMs(per 100,000 adults) of Austria in 2008 to that in 2012?
Keep it short and to the point. 0.95. What is the ratio of the ATMs(per 100,000 adults) of Thailand in 2008 to that in 2012?
Provide a short and direct response. 0.69. What is the ratio of the ATMs(per 100,000 adults) in Timor-Leste in 2008 to that in 2012?
Offer a terse response. 0.6. What is the ratio of the ATMs(per 100,000 adults) in Upper middle income in 2008 to that in 2013?
Offer a terse response. 0.65. What is the ratio of the ATMs(per 100,000 adults) of Austria in 2008 to that in 2013?
Your answer should be compact. 0.94. What is the ratio of the ATMs(per 100,000 adults) of Thailand in 2008 to that in 2013?
Give a very brief answer. 0.64. What is the ratio of the ATMs(per 100,000 adults) of Timor-Leste in 2008 to that in 2013?
Give a very brief answer. 0.68. What is the ratio of the ATMs(per 100,000 adults) of Upper middle income in 2009 to that in 2010?
Give a very brief answer. 0.95. What is the ratio of the ATMs(per 100,000 adults) in Thailand in 2009 to that in 2010?
Offer a terse response. 0.9. What is the ratio of the ATMs(per 100,000 adults) of Timor-Leste in 2009 to that in 2010?
Your answer should be compact. 0.82. What is the ratio of the ATMs(per 100,000 adults) in Upper middle income in 2009 to that in 2011?
Offer a terse response. 0.88. What is the ratio of the ATMs(per 100,000 adults) in Austria in 2009 to that in 2011?
Your answer should be compact. 0.99. What is the ratio of the ATMs(per 100,000 adults) of Thailand in 2009 to that in 2011?
Your answer should be compact. 0.84. What is the ratio of the ATMs(per 100,000 adults) of Timor-Leste in 2009 to that in 2011?
Offer a terse response. 0.72. What is the ratio of the ATMs(per 100,000 adults) in Upper middle income in 2009 to that in 2012?
Provide a succinct answer. 0.8. What is the ratio of the ATMs(per 100,000 adults) of Austria in 2009 to that in 2012?
Provide a succinct answer. 0.97. What is the ratio of the ATMs(per 100,000 adults) of Thailand in 2009 to that in 2012?
Offer a terse response. 0.77. What is the ratio of the ATMs(per 100,000 adults) in Timor-Leste in 2009 to that in 2012?
Provide a succinct answer. 0.58. What is the ratio of the ATMs(per 100,000 adults) in Upper middle income in 2009 to that in 2013?
Offer a very short reply. 0.74. What is the ratio of the ATMs(per 100,000 adults) of Austria in 2009 to that in 2013?
Your answer should be very brief. 0.96. What is the ratio of the ATMs(per 100,000 adults) in Thailand in 2009 to that in 2013?
Keep it short and to the point. 0.72. What is the ratio of the ATMs(per 100,000 adults) in Timor-Leste in 2009 to that in 2013?
Offer a terse response. 0.66. What is the ratio of the ATMs(per 100,000 adults) in Upper middle income in 2010 to that in 2011?
Offer a terse response. 0.92. What is the ratio of the ATMs(per 100,000 adults) in Thailand in 2010 to that in 2011?
Your response must be concise. 0.94. What is the ratio of the ATMs(per 100,000 adults) in Timor-Leste in 2010 to that in 2011?
Your answer should be very brief. 0.88. What is the ratio of the ATMs(per 100,000 adults) in Upper middle income in 2010 to that in 2012?
Your response must be concise. 0.84. What is the ratio of the ATMs(per 100,000 adults) in Austria in 2010 to that in 2012?
Your answer should be very brief. 0.98. What is the ratio of the ATMs(per 100,000 adults) of Thailand in 2010 to that in 2012?
Your answer should be compact. 0.87. What is the ratio of the ATMs(per 100,000 adults) in Timor-Leste in 2010 to that in 2012?
Give a very brief answer. 0.72. What is the ratio of the ATMs(per 100,000 adults) of Upper middle income in 2010 to that in 2013?
Ensure brevity in your answer.  0.78. What is the ratio of the ATMs(per 100,000 adults) of Austria in 2010 to that in 2013?
Keep it short and to the point. 0.96. What is the ratio of the ATMs(per 100,000 adults) in Thailand in 2010 to that in 2013?
Keep it short and to the point. 0.8. What is the ratio of the ATMs(per 100,000 adults) of Timor-Leste in 2010 to that in 2013?
Offer a terse response. 0.81. What is the ratio of the ATMs(per 100,000 adults) in Upper middle income in 2011 to that in 2012?
Your answer should be very brief. 0.91. What is the ratio of the ATMs(per 100,000 adults) in Austria in 2011 to that in 2012?
Your answer should be compact. 0.98. What is the ratio of the ATMs(per 100,000 adults) in Thailand in 2011 to that in 2012?
Keep it short and to the point. 0.92. What is the ratio of the ATMs(per 100,000 adults) in Timor-Leste in 2011 to that in 2012?
Offer a terse response. 0.81. What is the ratio of the ATMs(per 100,000 adults) of Upper middle income in 2011 to that in 2013?
Ensure brevity in your answer.  0.85. What is the ratio of the ATMs(per 100,000 adults) in Austria in 2011 to that in 2013?
Provide a short and direct response. 0.97. What is the ratio of the ATMs(per 100,000 adults) in Thailand in 2011 to that in 2013?
Make the answer very short. 0.85. What is the ratio of the ATMs(per 100,000 adults) in Timor-Leste in 2011 to that in 2013?
Your answer should be compact. 0.92. What is the ratio of the ATMs(per 100,000 adults) in Upper middle income in 2012 to that in 2013?
Offer a terse response. 0.93. What is the ratio of the ATMs(per 100,000 adults) in Austria in 2012 to that in 2013?
Your answer should be very brief. 0.98. What is the ratio of the ATMs(per 100,000 adults) in Thailand in 2012 to that in 2013?
Offer a very short reply. 0.93. What is the ratio of the ATMs(per 100,000 adults) of Timor-Leste in 2012 to that in 2013?
Your response must be concise. 1.14. What is the difference between the highest and the second highest ATMs(per 100,000 adults) of Upper middle income?
Provide a short and direct response. 3.09. What is the difference between the highest and the second highest ATMs(per 100,000 adults) in Austria?
Offer a very short reply. 1.77. What is the difference between the highest and the second highest ATMs(per 100,000 adults) of Thailand?
Give a very brief answer. 7.65. What is the difference between the highest and the second highest ATMs(per 100,000 adults) in Timor-Leste?
Your response must be concise. 0.45. What is the difference between the highest and the lowest ATMs(per 100,000 adults) of Upper middle income?
Keep it short and to the point. 15.51. What is the difference between the highest and the lowest ATMs(per 100,000 adults) in Austria?
Give a very brief answer. 7.44. What is the difference between the highest and the lowest ATMs(per 100,000 adults) in Thailand?
Your answer should be very brief. 37.42. What is the difference between the highest and the lowest ATMs(per 100,000 adults) in Timor-Leste?
Provide a short and direct response. 1.55. 